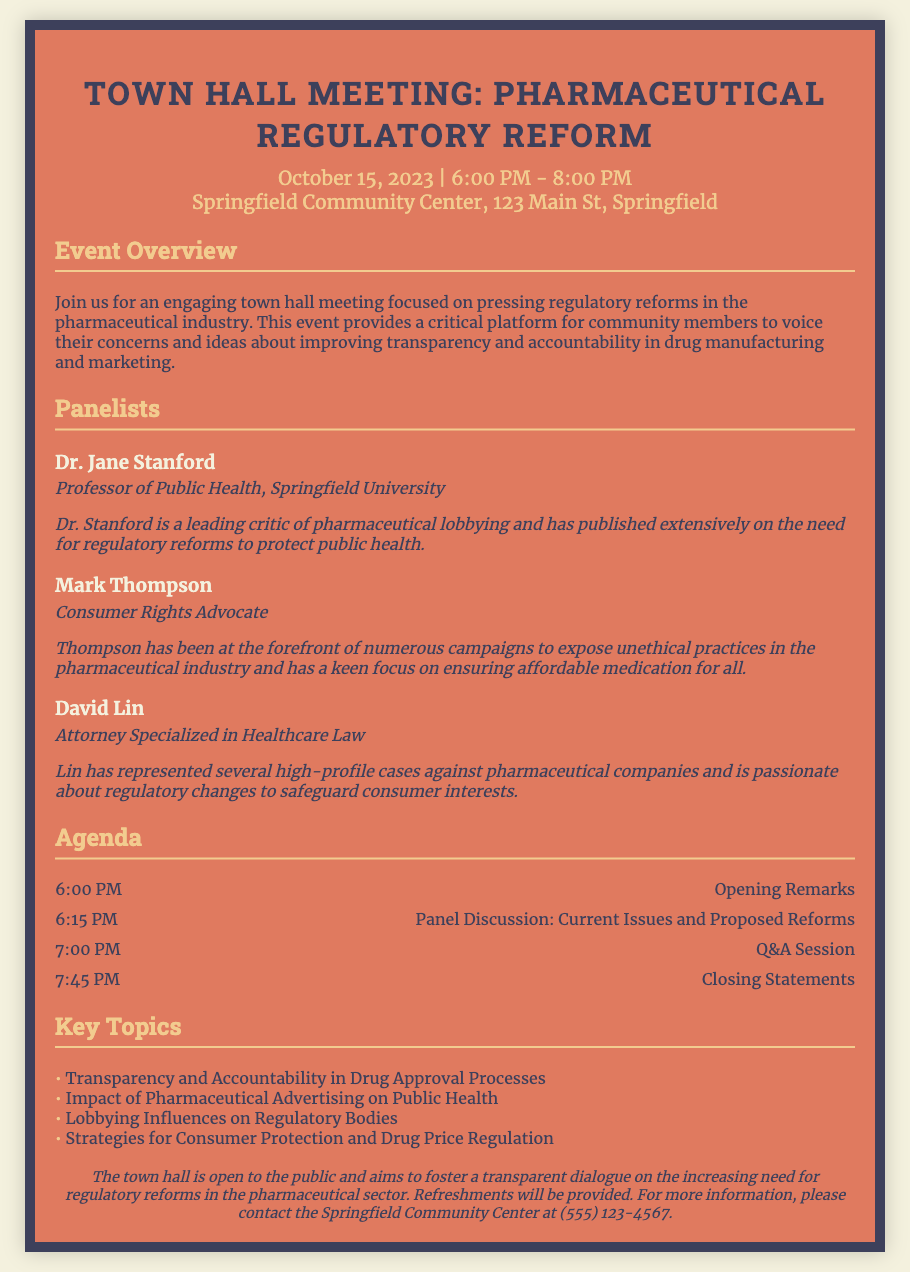What date is the event scheduled for? The date of the event is stated clearly in the document under the event details section, which is October 15, 2023.
Answer: October 15, 2023 Who is the first panelist mentioned? The first panelist listed in the document is Dr. Jane Stanford, as per the panelists section.
Answer: Dr. Jane Stanford What time does the Q&A session start? The start time of the Q&A session is provided in the agenda section of the document as 7:00 PM.
Answer: 7:00 PM What is the main purpose of the town hall meeting? The main purpose of the meeting is described in the overview section, focusing on regulatory reforms in the pharmaceutical industry.
Answer: Regulatory reforms How many panelists are there? The document mentions three panelists in total, as listed under the panelists section.
Answer: Three panelists What is one of the key topics listed for discussion? The document provides a list of key topics, one being "Impact of Pharmaceutical Advertising on Public Health."
Answer: Impact of Pharmaceutical Advertising on Public Health What is provided at the town hall meeting? The additional information section notes that refreshments will be provided during the event.
Answer: Refreshments Where is the event taking place? The location of the event is mentioned in the event details, specifying the Springfield Community Center, 123 Main St, Springfield.
Answer: Springfield Community Center, 123 Main St, Springfield 